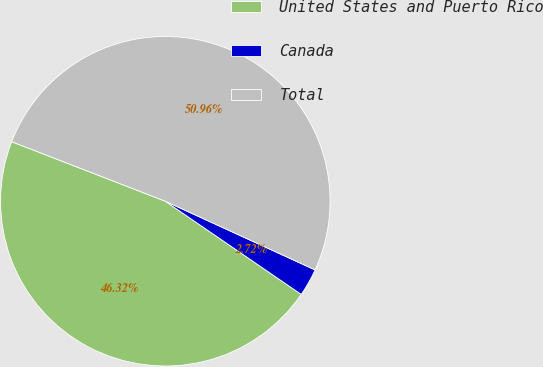Convert chart to OTSL. <chart><loc_0><loc_0><loc_500><loc_500><pie_chart><fcel>United States and Puerto Rico<fcel>Canada<fcel>Total<nl><fcel>46.32%<fcel>2.72%<fcel>50.96%<nl></chart> 